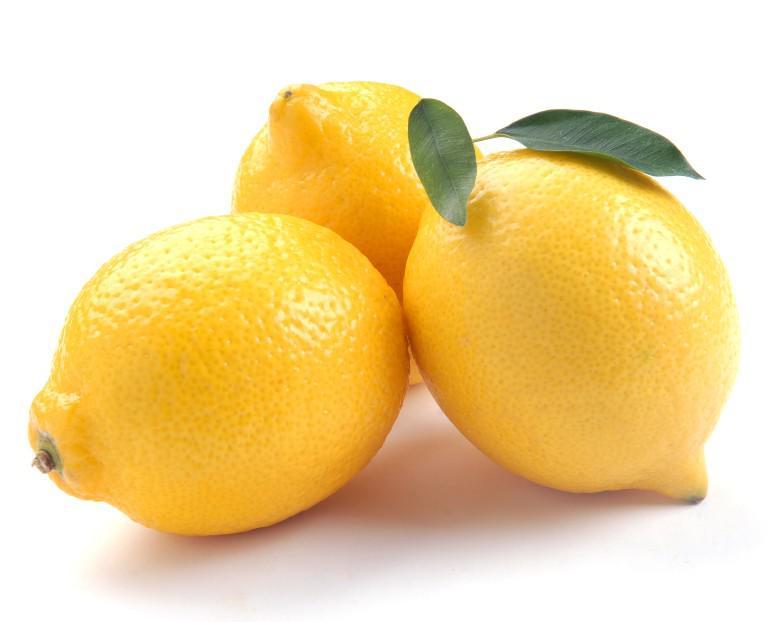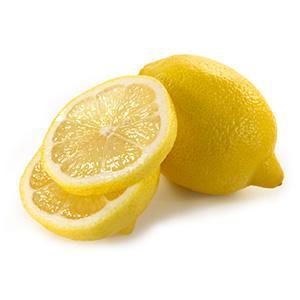The first image is the image on the left, the second image is the image on the right. Considering the images on both sides, is "One image includes whole and half lemons." valid? Answer yes or no. Yes. The first image is the image on the left, the second image is the image on the right. Evaluate the accuracy of this statement regarding the images: "Lemon slices appear in one image, while a second image includes one or more whole lemons.". Is it true? Answer yes or no. Yes. 